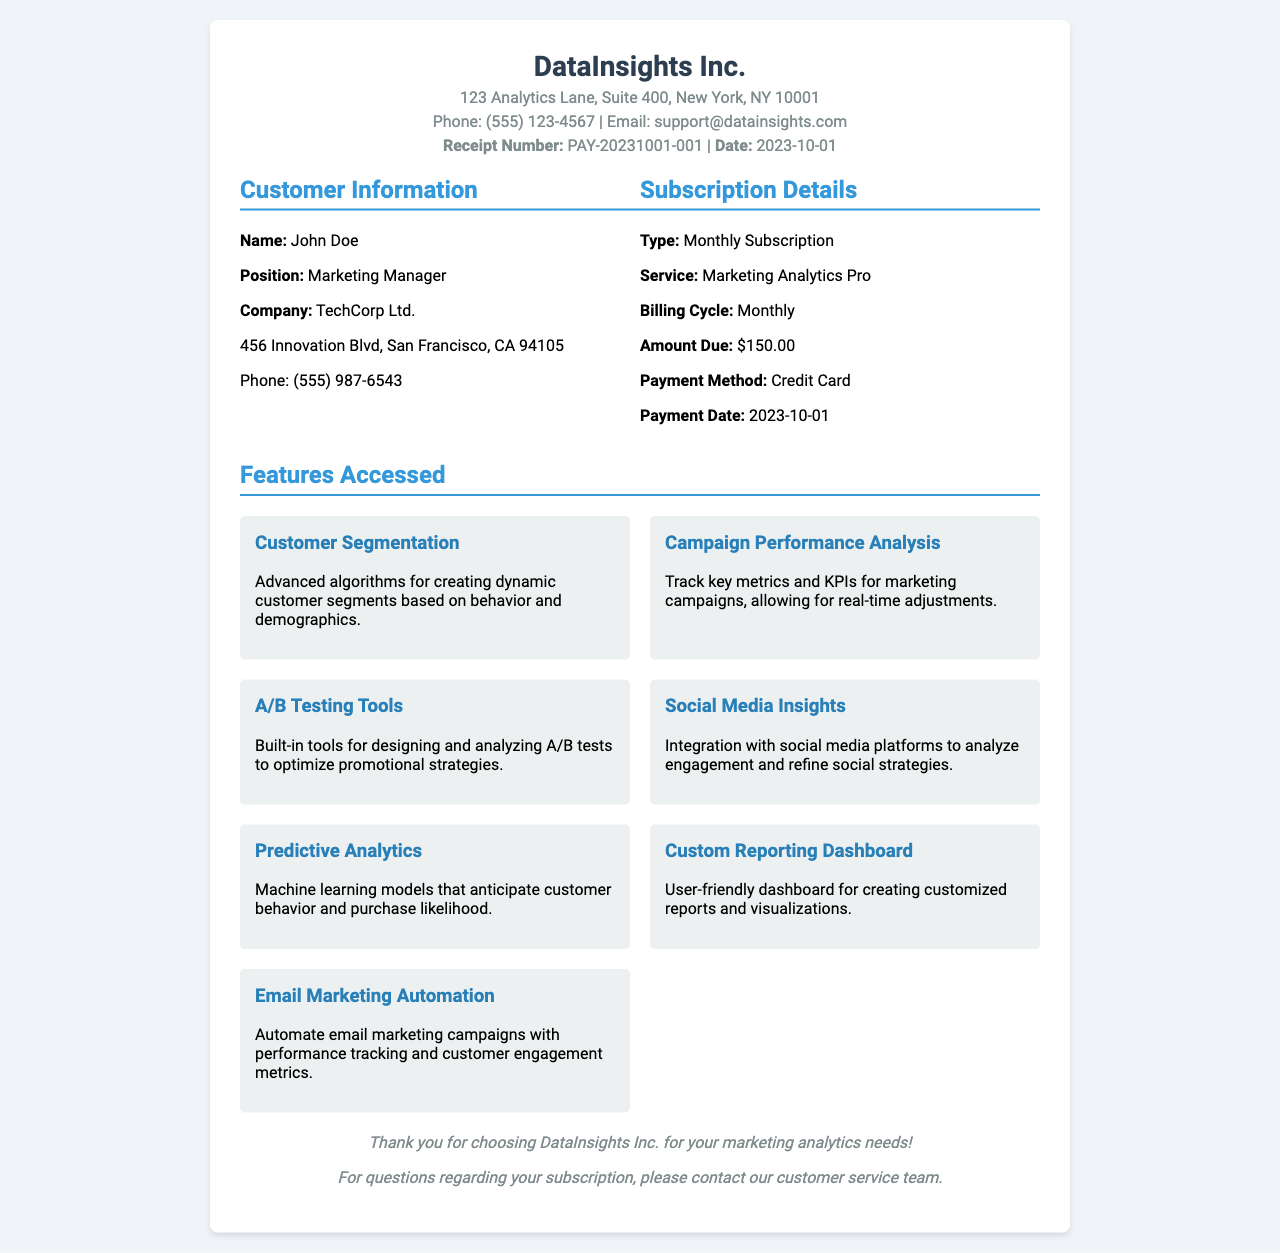What is the company name? The company name is mentioned at the top of the receipt, which is DataInsights Inc.
Answer: DataInsights Inc What is the receipt number? The receipt number is specified in the document as PAY-20231001-001.
Answer: PAY-20231001-001 What is the amount due for the subscription? The amount due is listed under subscription details in the document as $150.00.
Answer: $150.00 When was the payment made? The payment date indicates when the transaction occurred, which is 2023-10-01.
Answer: 2023-10-01 What features are included in the subscription? The document details several features in the 'Features Accessed' section, including Customer Segmentation and Campaign Performance Analysis.
Answer: Customer Segmentation, Campaign Performance Analysis, A/B Testing Tools, Social Media Insights, Predictive Analytics, Custom Reporting Dashboard, Email Marketing Automation What is the position of the customer? The customer's position is mentioned under customer information as Marketing Manager.
Answer: Marketing Manager Which payment method was used? The payment method used for the subscription is specified as Credit Card.
Answer: Credit Card What type of subscription is this receipt for? The subscription type is mentioned clearly in the document as Monthly Subscription.
Answer: Monthly Subscription How many features are listed in the document? The document lists a total of seven features accessed under the subscription details.
Answer: Seven 